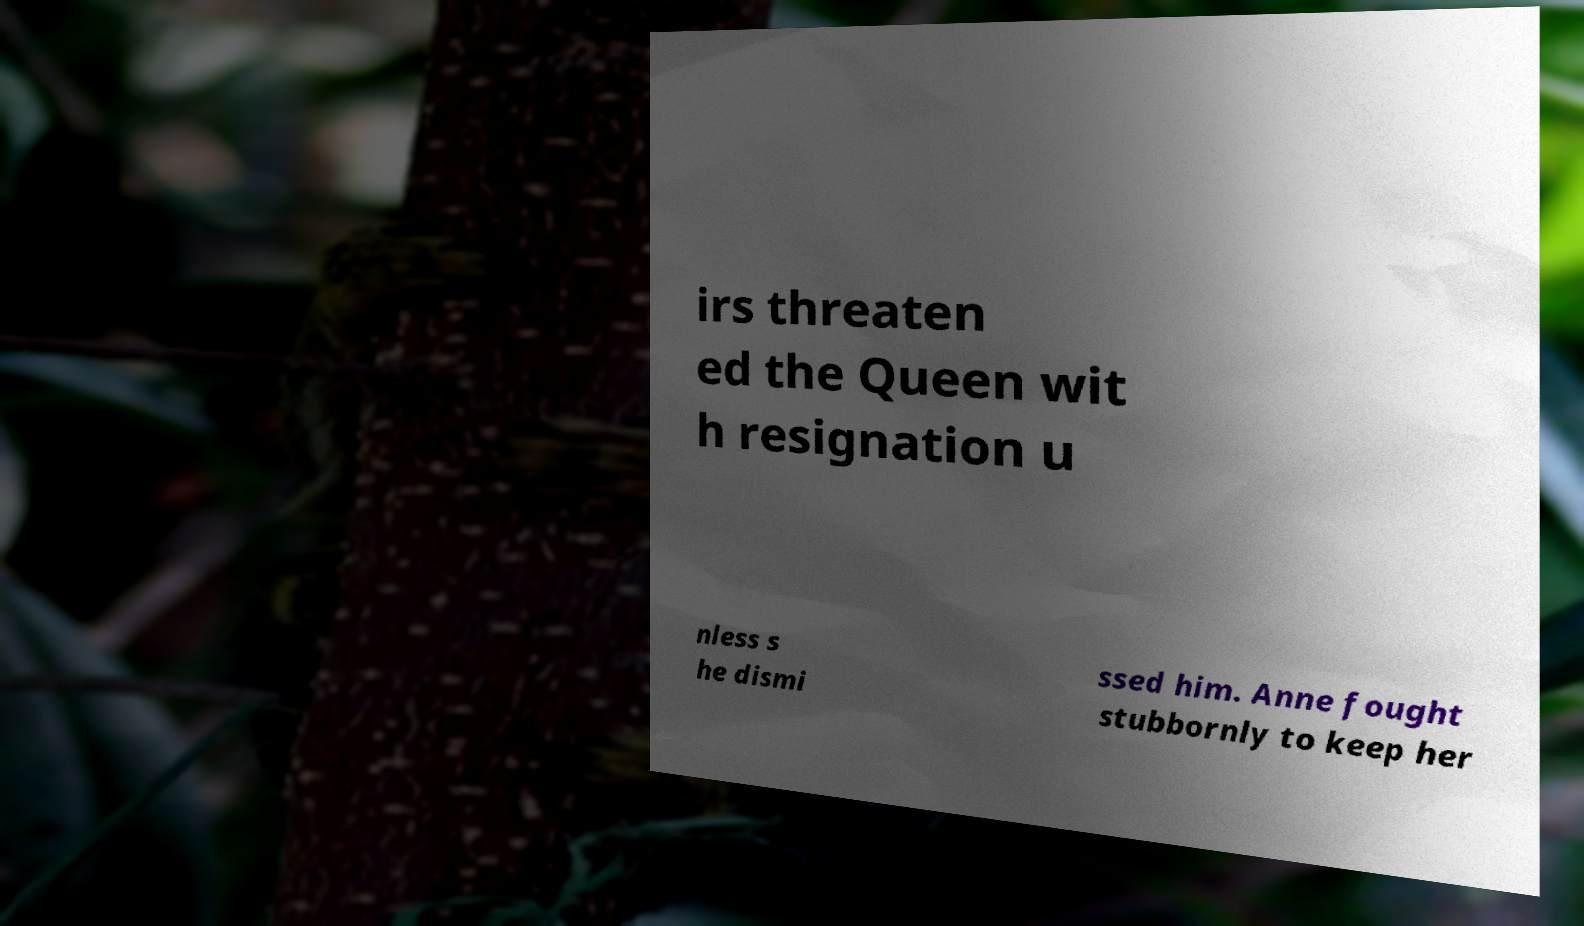Can you accurately transcribe the text from the provided image for me? irs threaten ed the Queen wit h resignation u nless s he dismi ssed him. Anne fought stubbornly to keep her 